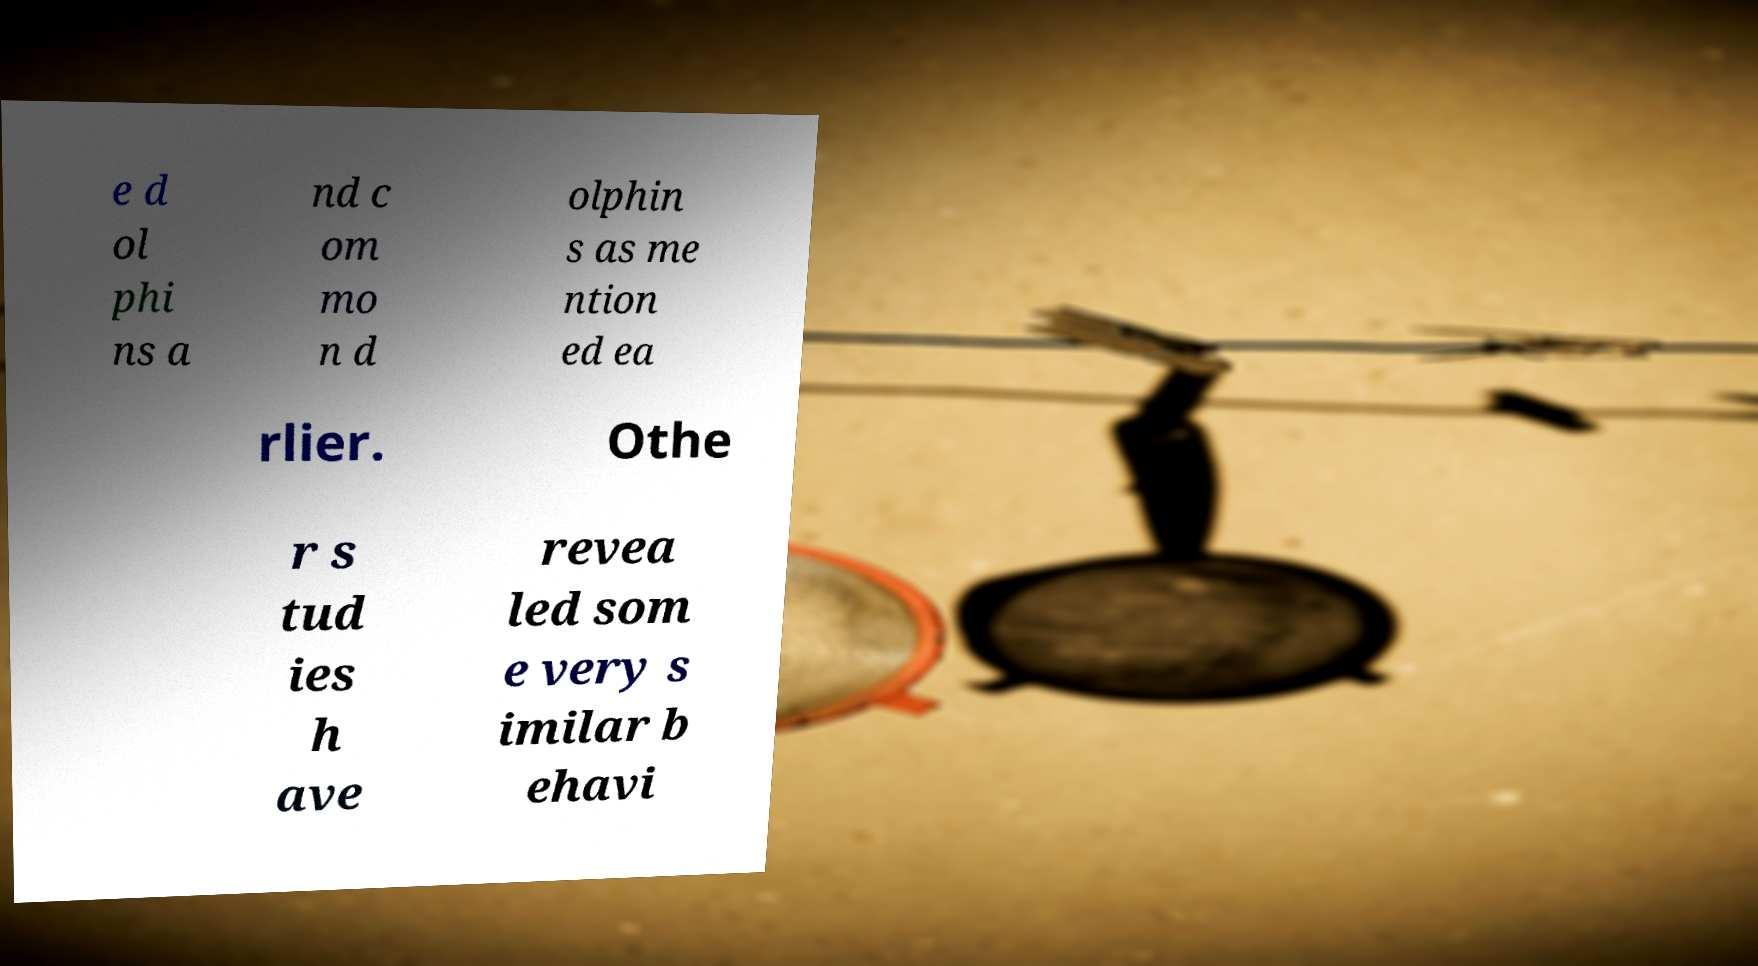Please read and relay the text visible in this image. What does it say? e d ol phi ns a nd c om mo n d olphin s as me ntion ed ea rlier. Othe r s tud ies h ave revea led som e very s imilar b ehavi 